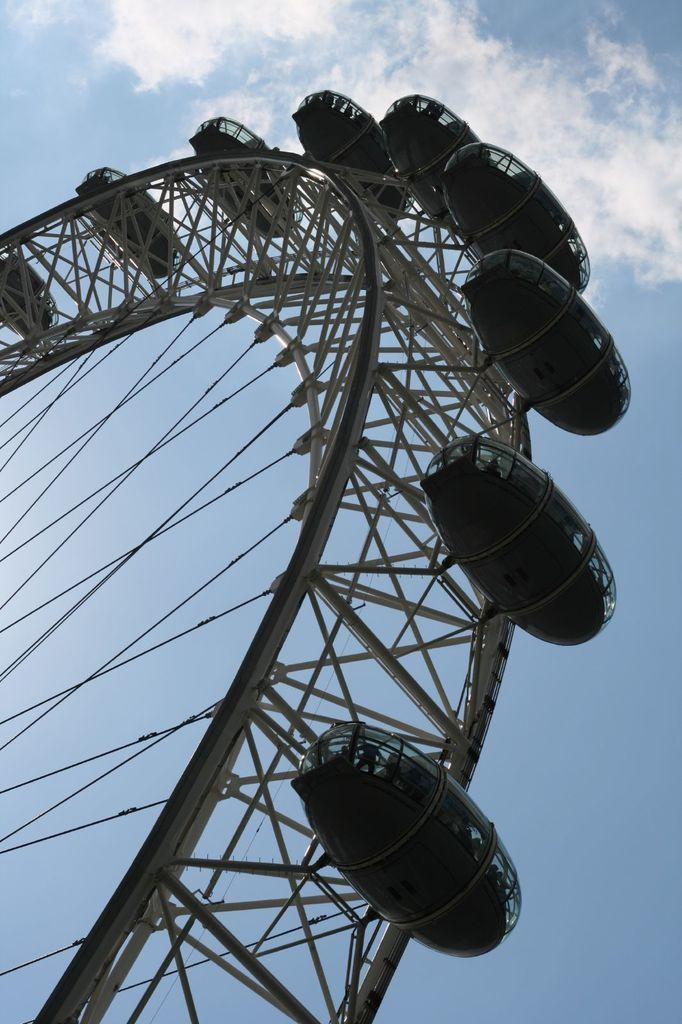What is the main subject of the image? There is a Ferris wheel in the image. What can be seen in the background of the image? The sky is visible in the background of the image. How would you describe the sky in the image? The sky appears to be cloudy. What type of canvas is being used by the person with the crooked boot in the image? There is no person with a crooked boot or any canvas present in the image; it features a Ferris wheel and a cloudy sky. 